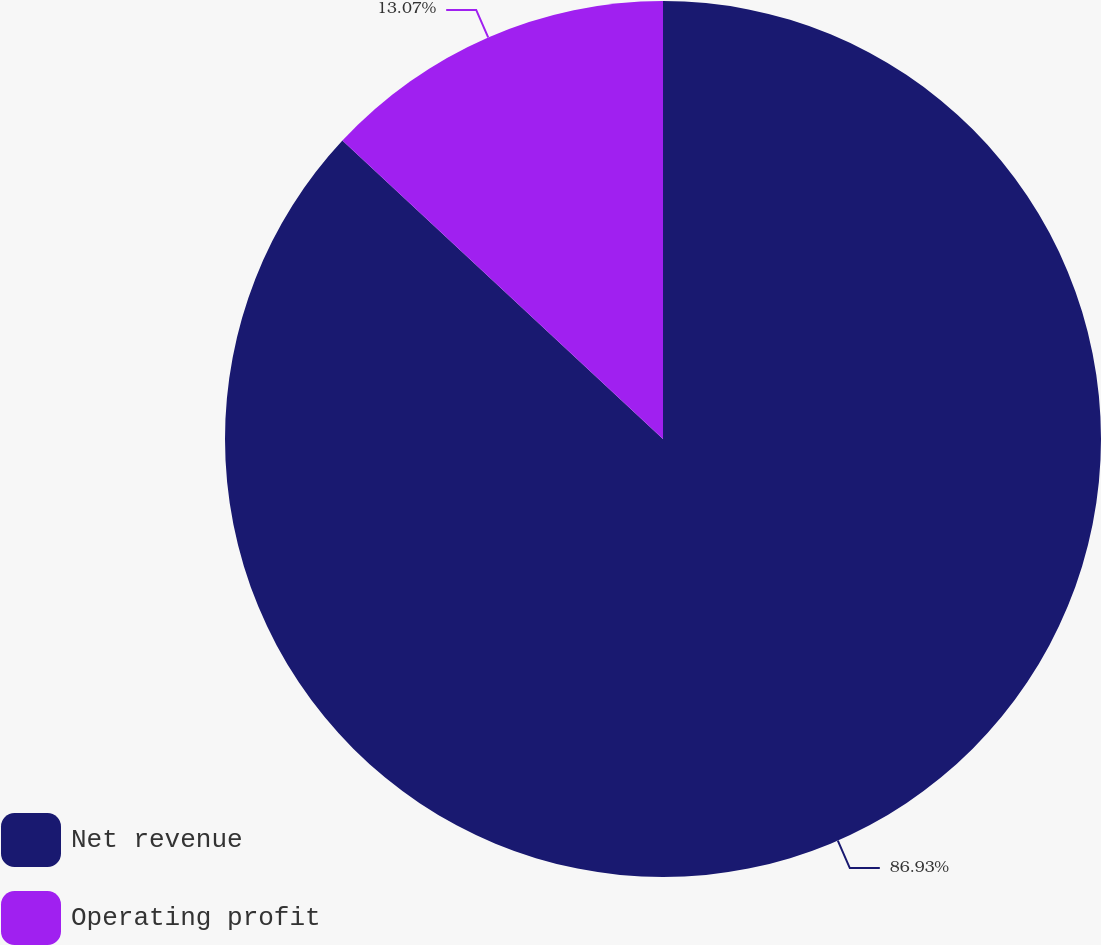<chart> <loc_0><loc_0><loc_500><loc_500><pie_chart><fcel>Net revenue<fcel>Operating profit<nl><fcel>86.93%<fcel>13.07%<nl></chart> 